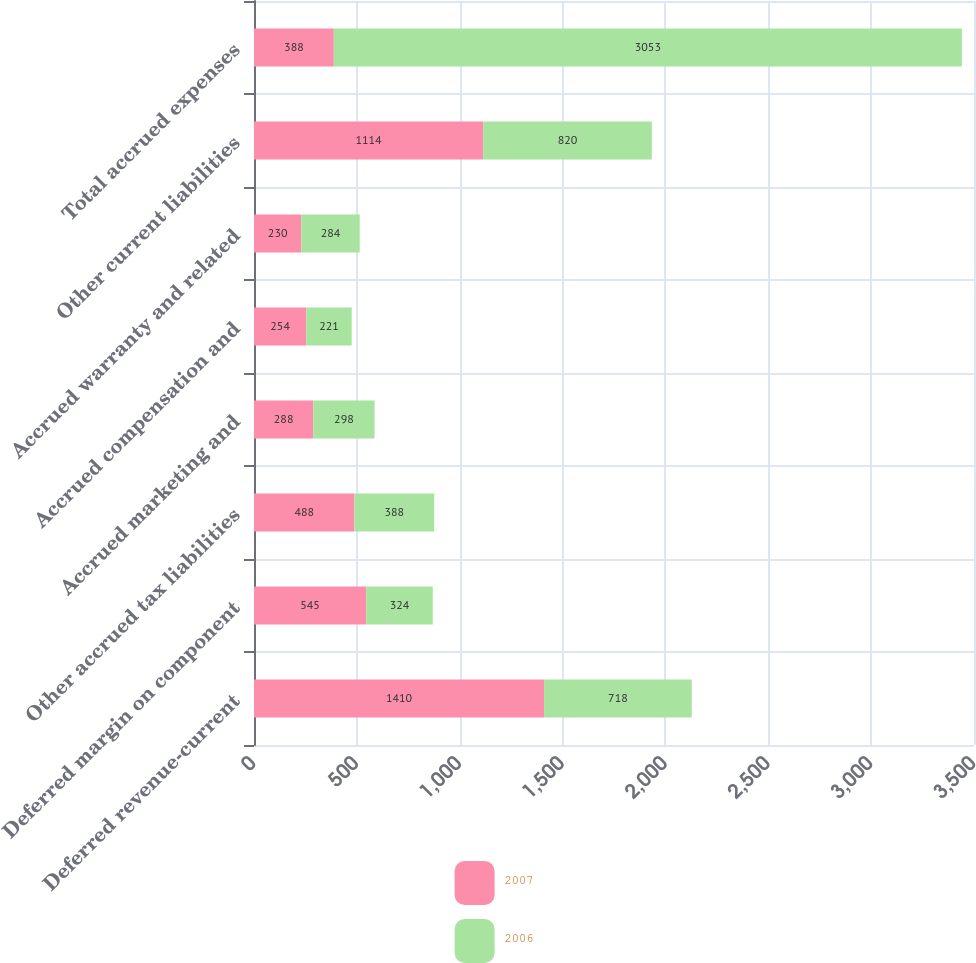Convert chart to OTSL. <chart><loc_0><loc_0><loc_500><loc_500><stacked_bar_chart><ecel><fcel>Deferred revenue-current<fcel>Deferred margin on component<fcel>Other accrued tax liabilities<fcel>Accrued marketing and<fcel>Accrued compensation and<fcel>Accrued warranty and related<fcel>Other current liabilities<fcel>Total accrued expenses<nl><fcel>2007<fcel>1410<fcel>545<fcel>488<fcel>288<fcel>254<fcel>230<fcel>1114<fcel>388<nl><fcel>2006<fcel>718<fcel>324<fcel>388<fcel>298<fcel>221<fcel>284<fcel>820<fcel>3053<nl></chart> 